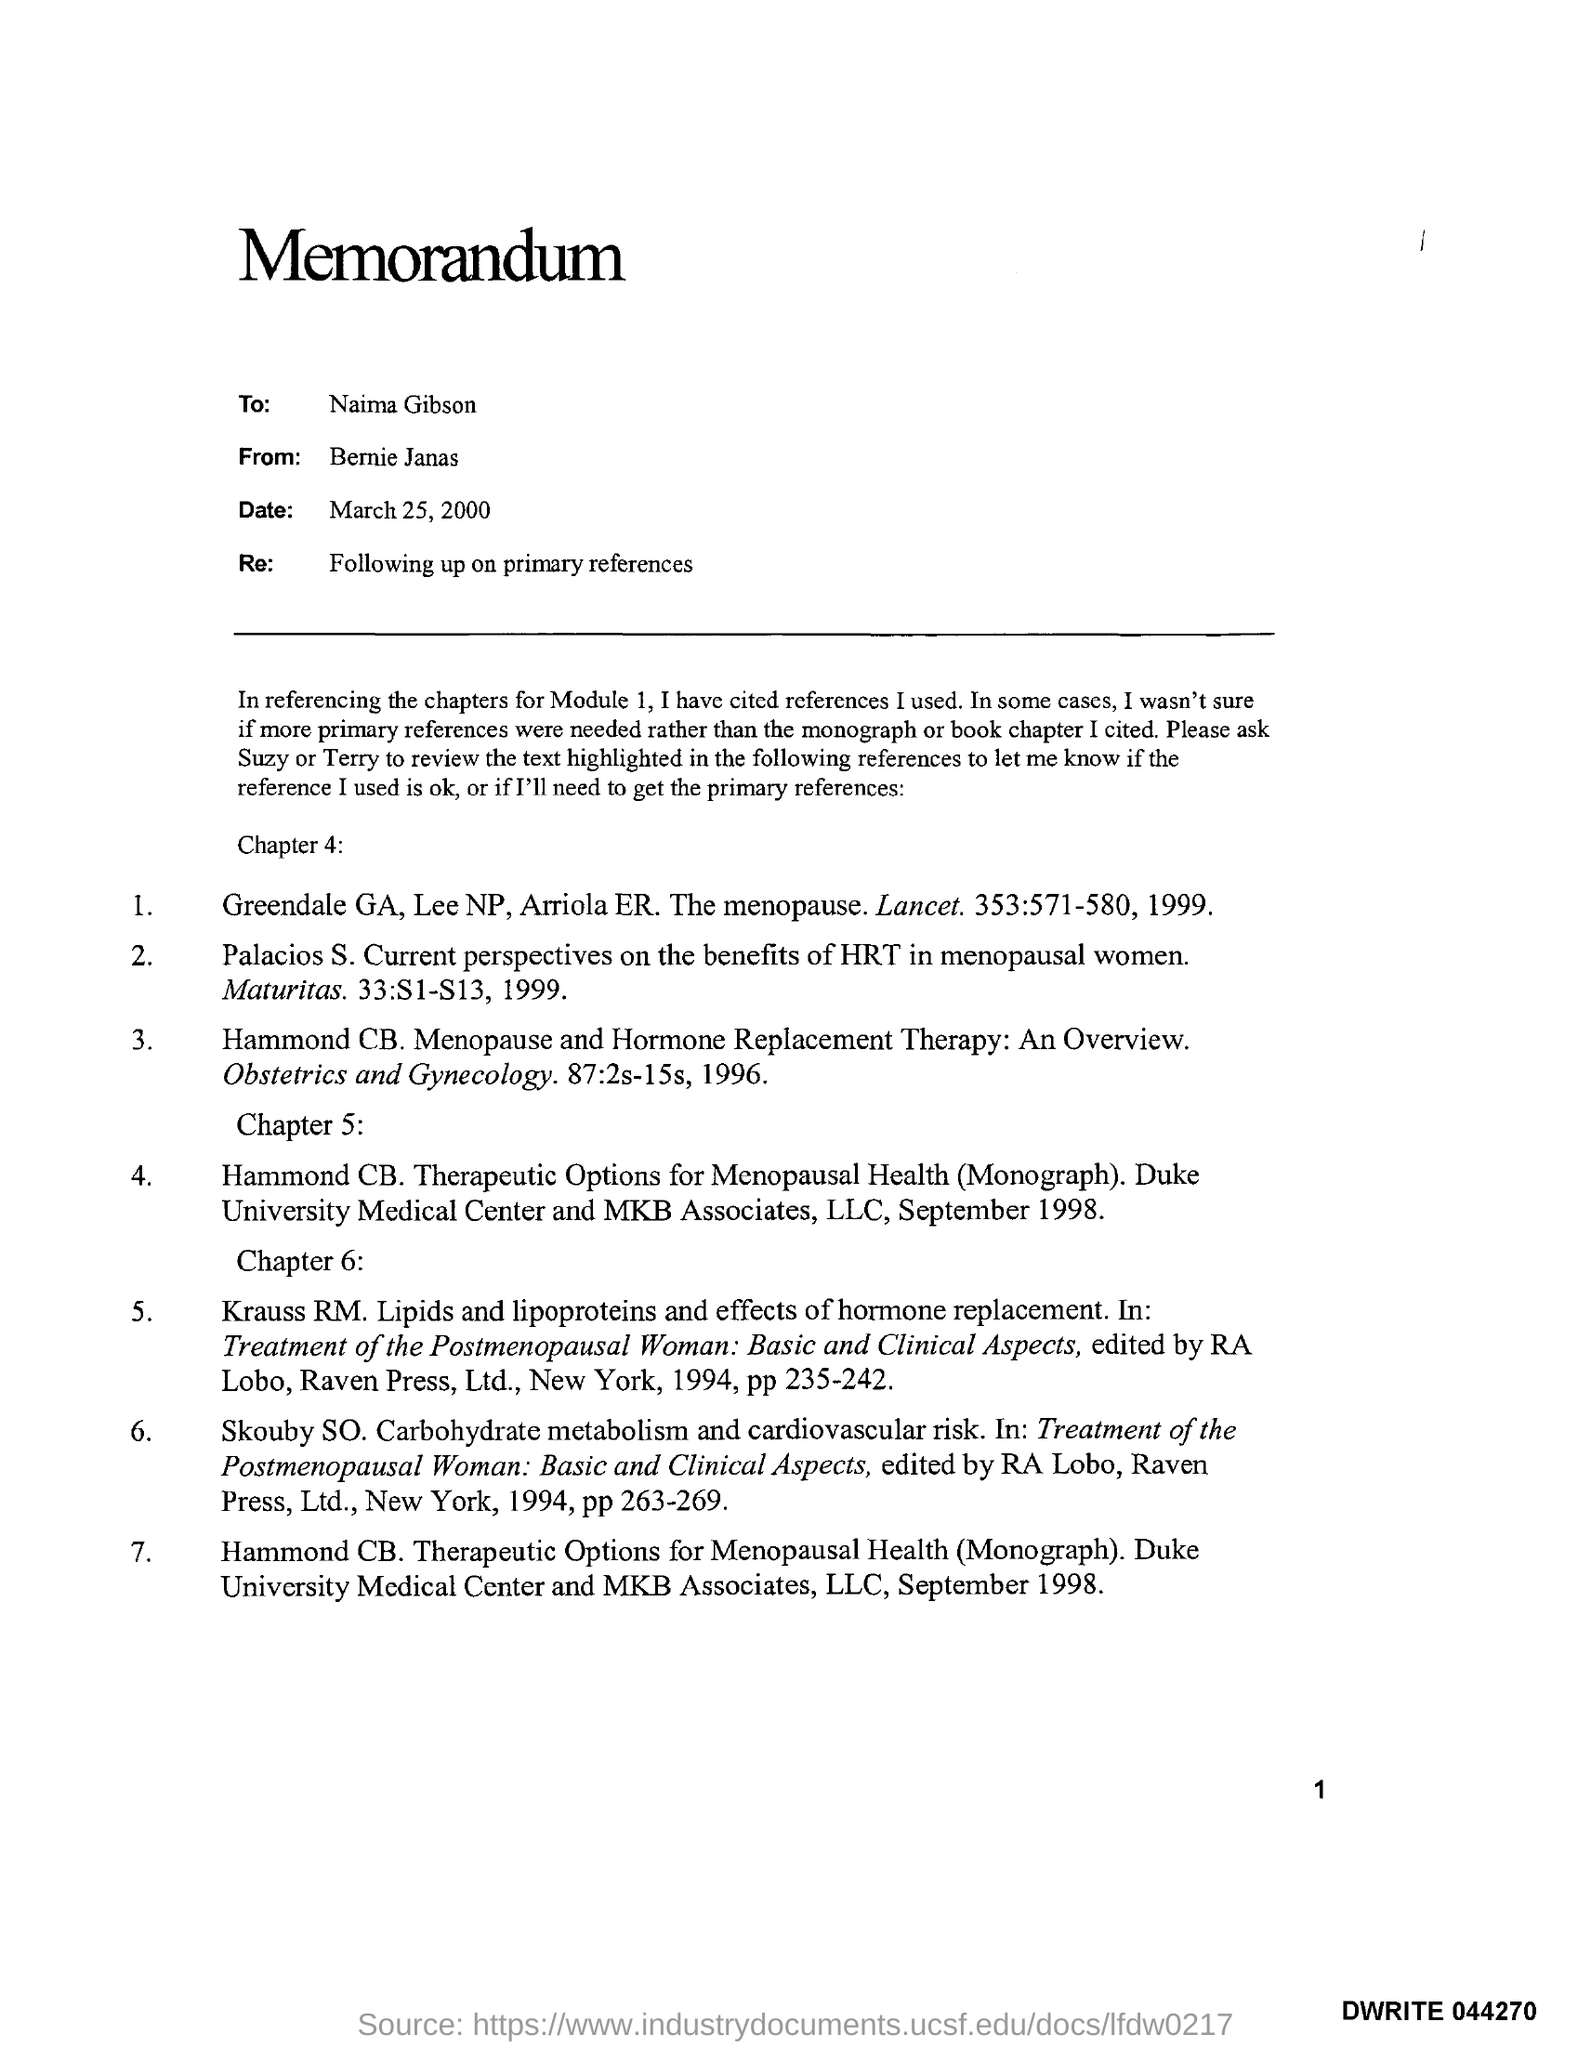Mention a couple of crucial points in this snapshot. The letter head contains a memorandum. The date mentioned at the top of the document is March 25, 2000. The memorandum is from Bernie Janas. The memorandum is addressed to Naima Gibson. The Re field contains information about additional references that support the information in the bibliographic record. 